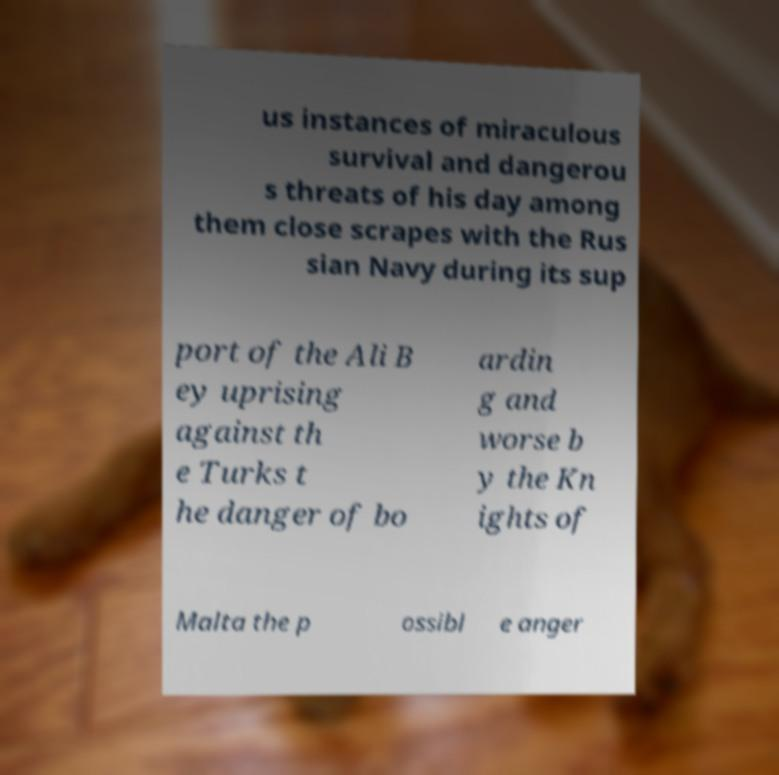What messages or text are displayed in this image? I need them in a readable, typed format. us instances of miraculous survival and dangerou s threats of his day among them close scrapes with the Rus sian Navy during its sup port of the Ali B ey uprising against th e Turks t he danger of bo ardin g and worse b y the Kn ights of Malta the p ossibl e anger 